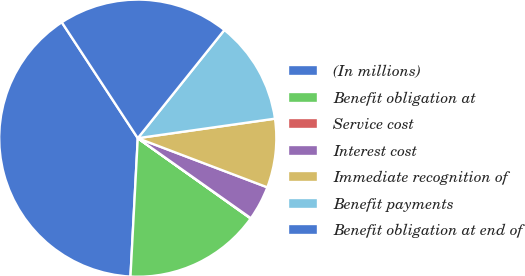Convert chart to OTSL. <chart><loc_0><loc_0><loc_500><loc_500><pie_chart><fcel>(In millions)<fcel>Benefit obligation at<fcel>Service cost<fcel>Interest cost<fcel>Immediate recognition of<fcel>Benefit payments<fcel>Benefit obligation at end of<nl><fcel>39.93%<fcel>16.0%<fcel>0.04%<fcel>4.03%<fcel>8.02%<fcel>12.01%<fcel>19.98%<nl></chart> 